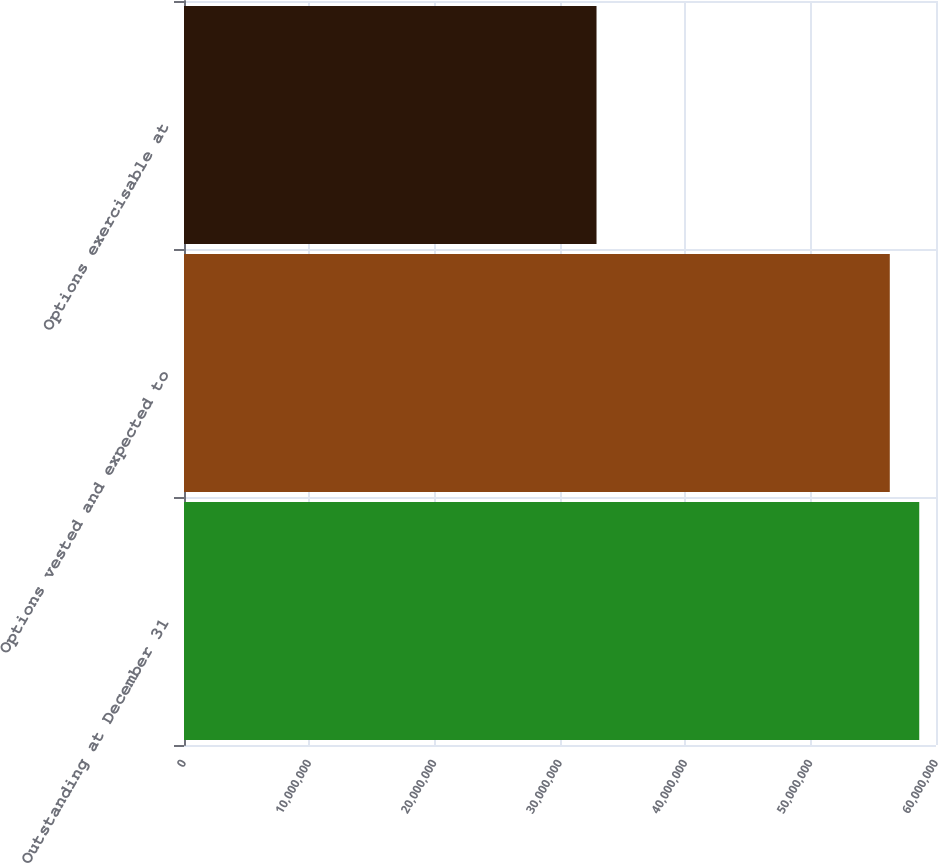Convert chart. <chart><loc_0><loc_0><loc_500><loc_500><bar_chart><fcel>Outstanding at December 31<fcel>Options vested and expected to<fcel>Options exercisable at<nl><fcel>5.8663e+07<fcel>5.6313e+07<fcel>3.2914e+07<nl></chart> 